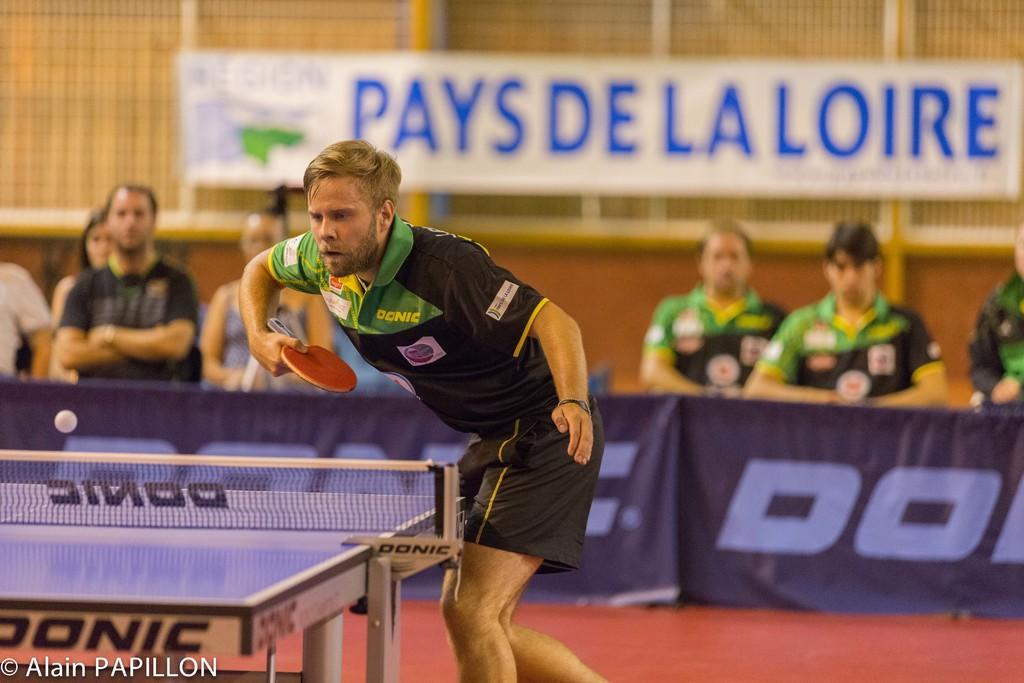Could you give a brief overview of what you see in this image? In this image I can see a person playing table tennis. I can see a table, net, a ball and a table tennis bat in his hand. I can see some people standing and some people sitting behind him and watching him. I can see a banner at the top of the image with some text and the background is blurred. 